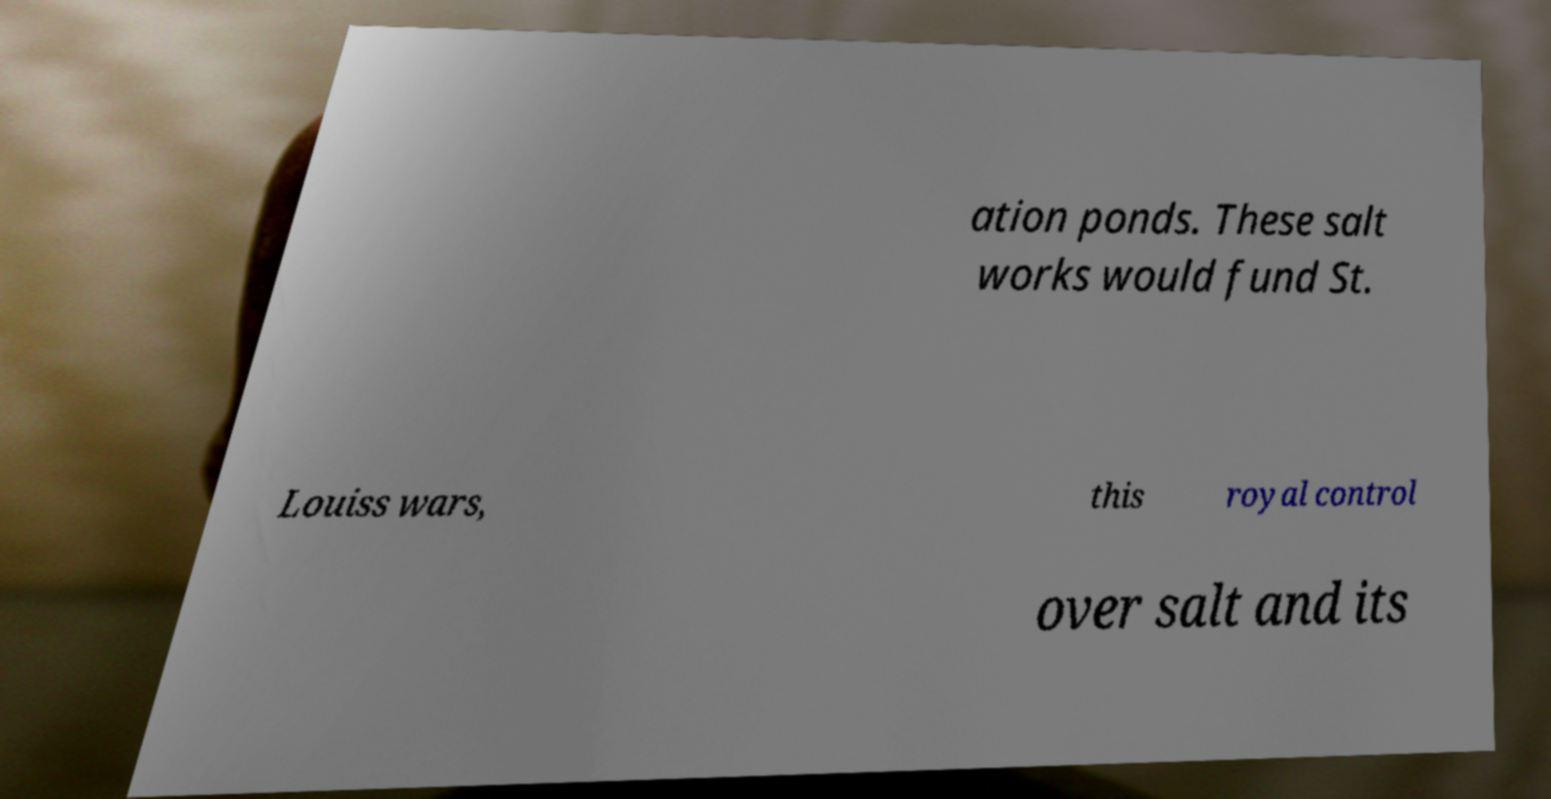Can you accurately transcribe the text from the provided image for me? ation ponds. These salt works would fund St. Louiss wars, this royal control over salt and its 